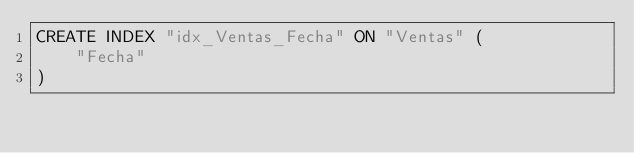Convert code to text. <code><loc_0><loc_0><loc_500><loc_500><_SQL_>CREATE INDEX "idx_Ventas_Fecha" ON "Ventas" (
	"Fecha"
)</code> 